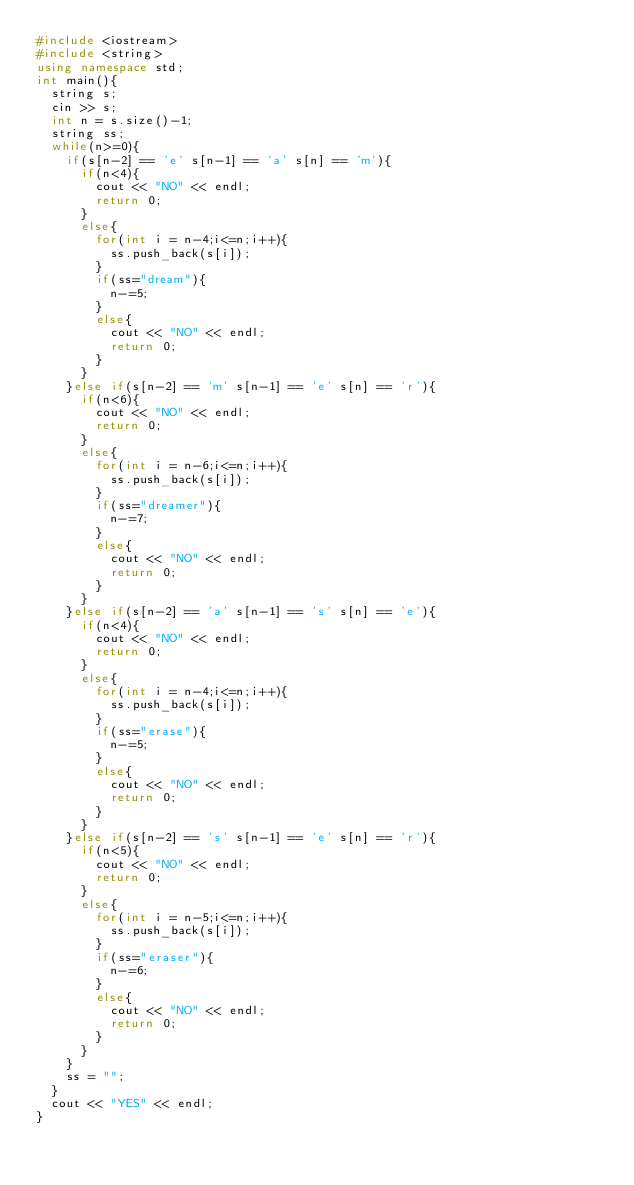<code> <loc_0><loc_0><loc_500><loc_500><_C++_>#include <iostream>
#include <string>
using namespace std;
int main(){
  string s;
  cin >> s;
  int n = s.size()-1;
  string ss;
  while(n>=0){
    if(s[n-2] == 'e' s[n-1] == 'a' s[n] == 'm'){
      if(n<4){
        cout << "NO" << endl;
        return 0;
      }
      else{
        for(int i = n-4;i<=n;i++){
          ss.push_back(s[i]);
        }
        if(ss="dream"){
          n-=5;
        }
        else{
          cout << "NO" << endl;
          return 0;
        }
      }
    }else if(s[n-2] == 'm' s[n-1] == 'e' s[n] == 'r'){
      if(n<6){
        cout << "NO" << endl;
        return 0;
      }
      else{
        for(int i = n-6;i<=n;i++){
          ss.push_back(s[i]);
        }
        if(ss="dreamer"){
          n-=7;
        }
        else{
          cout << "NO" << endl;
          return 0;
        }
      }
    }else if(s[n-2] == 'a' s[n-1] == 's' s[n] == 'e'){
      if(n<4){
        cout << "NO" << endl;
        return 0;
      }
      else{
        for(int i = n-4;i<=n;i++){
          ss.push_back(s[i]);
        }
        if(ss="erase"){
          n-=5;
        }
        else{
          cout << "NO" << endl;
          return 0;
        }
      }
    }else if(s[n-2] == 's' s[n-1] == 'e' s[n] == 'r'){
      if(n<5){
        cout << "NO" << endl;
        return 0;
      }
      else{
        for(int i = n-5;i<=n;i++){
          ss.push_back(s[i]);
        }
        if(ss="eraser"){
          n-=6;
        }
        else{
          cout << "NO" << endl;
          return 0;
        }
      }
    }
    ss = "";
  }
  cout << "YES" << endl;
}
        
  </code> 